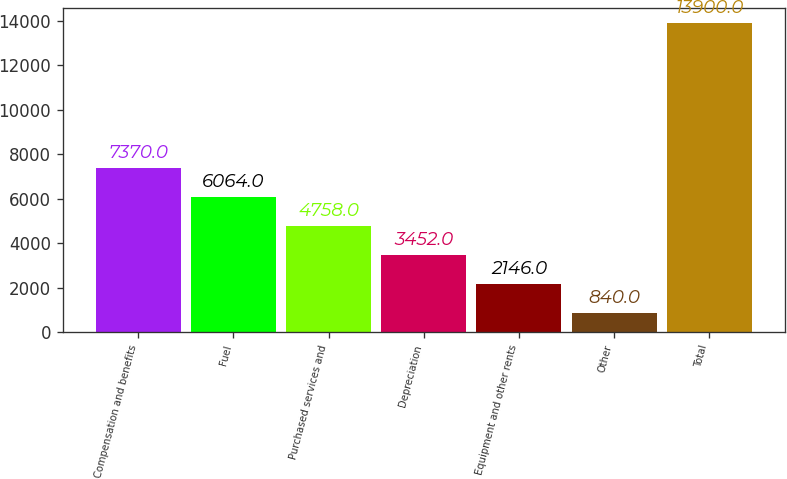Convert chart to OTSL. <chart><loc_0><loc_0><loc_500><loc_500><bar_chart><fcel>Compensation and benefits<fcel>Fuel<fcel>Purchased services and<fcel>Depreciation<fcel>Equipment and other rents<fcel>Other<fcel>Total<nl><fcel>7370<fcel>6064<fcel>4758<fcel>3452<fcel>2146<fcel>840<fcel>13900<nl></chart> 